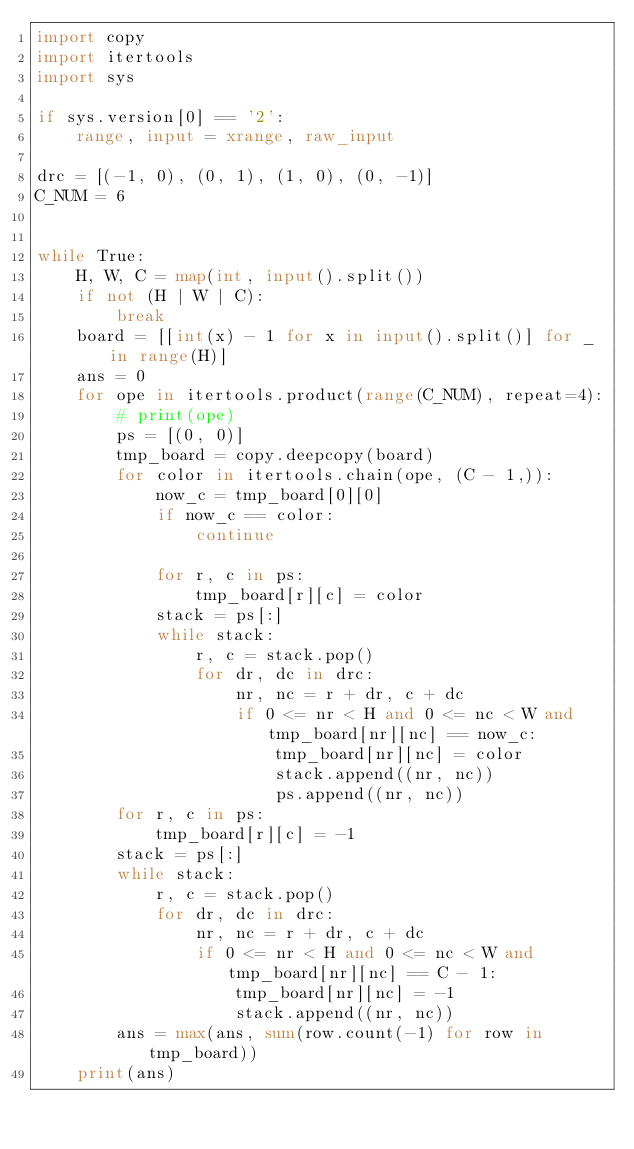Convert code to text. <code><loc_0><loc_0><loc_500><loc_500><_Python_>import copy
import itertools
import sys

if sys.version[0] == '2':
    range, input = xrange, raw_input

drc = [(-1, 0), (0, 1), (1, 0), (0, -1)]
C_NUM = 6


while True:
    H, W, C = map(int, input().split())
    if not (H | W | C):
        break
    board = [[int(x) - 1 for x in input().split()] for _ in range(H)]
    ans = 0
    for ope in itertools.product(range(C_NUM), repeat=4):
        # print(ope)
        ps = [(0, 0)]
        tmp_board = copy.deepcopy(board)
        for color in itertools.chain(ope, (C - 1,)):
            now_c = tmp_board[0][0]
            if now_c == color:
                continue

            for r, c in ps:
                tmp_board[r][c] = color
            stack = ps[:]
            while stack:
                r, c = stack.pop()
                for dr, dc in drc:
                    nr, nc = r + dr, c + dc
                    if 0 <= nr < H and 0 <= nc < W and tmp_board[nr][nc] == now_c:
                        tmp_board[nr][nc] = color
                        stack.append((nr, nc))
                        ps.append((nr, nc))
        for r, c in ps:
            tmp_board[r][c] = -1
        stack = ps[:]
        while stack:
            r, c = stack.pop()
            for dr, dc in drc:
                nr, nc = r + dr, c + dc
                if 0 <= nr < H and 0 <= nc < W and tmp_board[nr][nc] == C - 1:
                    tmp_board[nr][nc] = -1
                    stack.append((nr, nc))
        ans = max(ans, sum(row.count(-1) for row in tmp_board))
    print(ans)</code> 